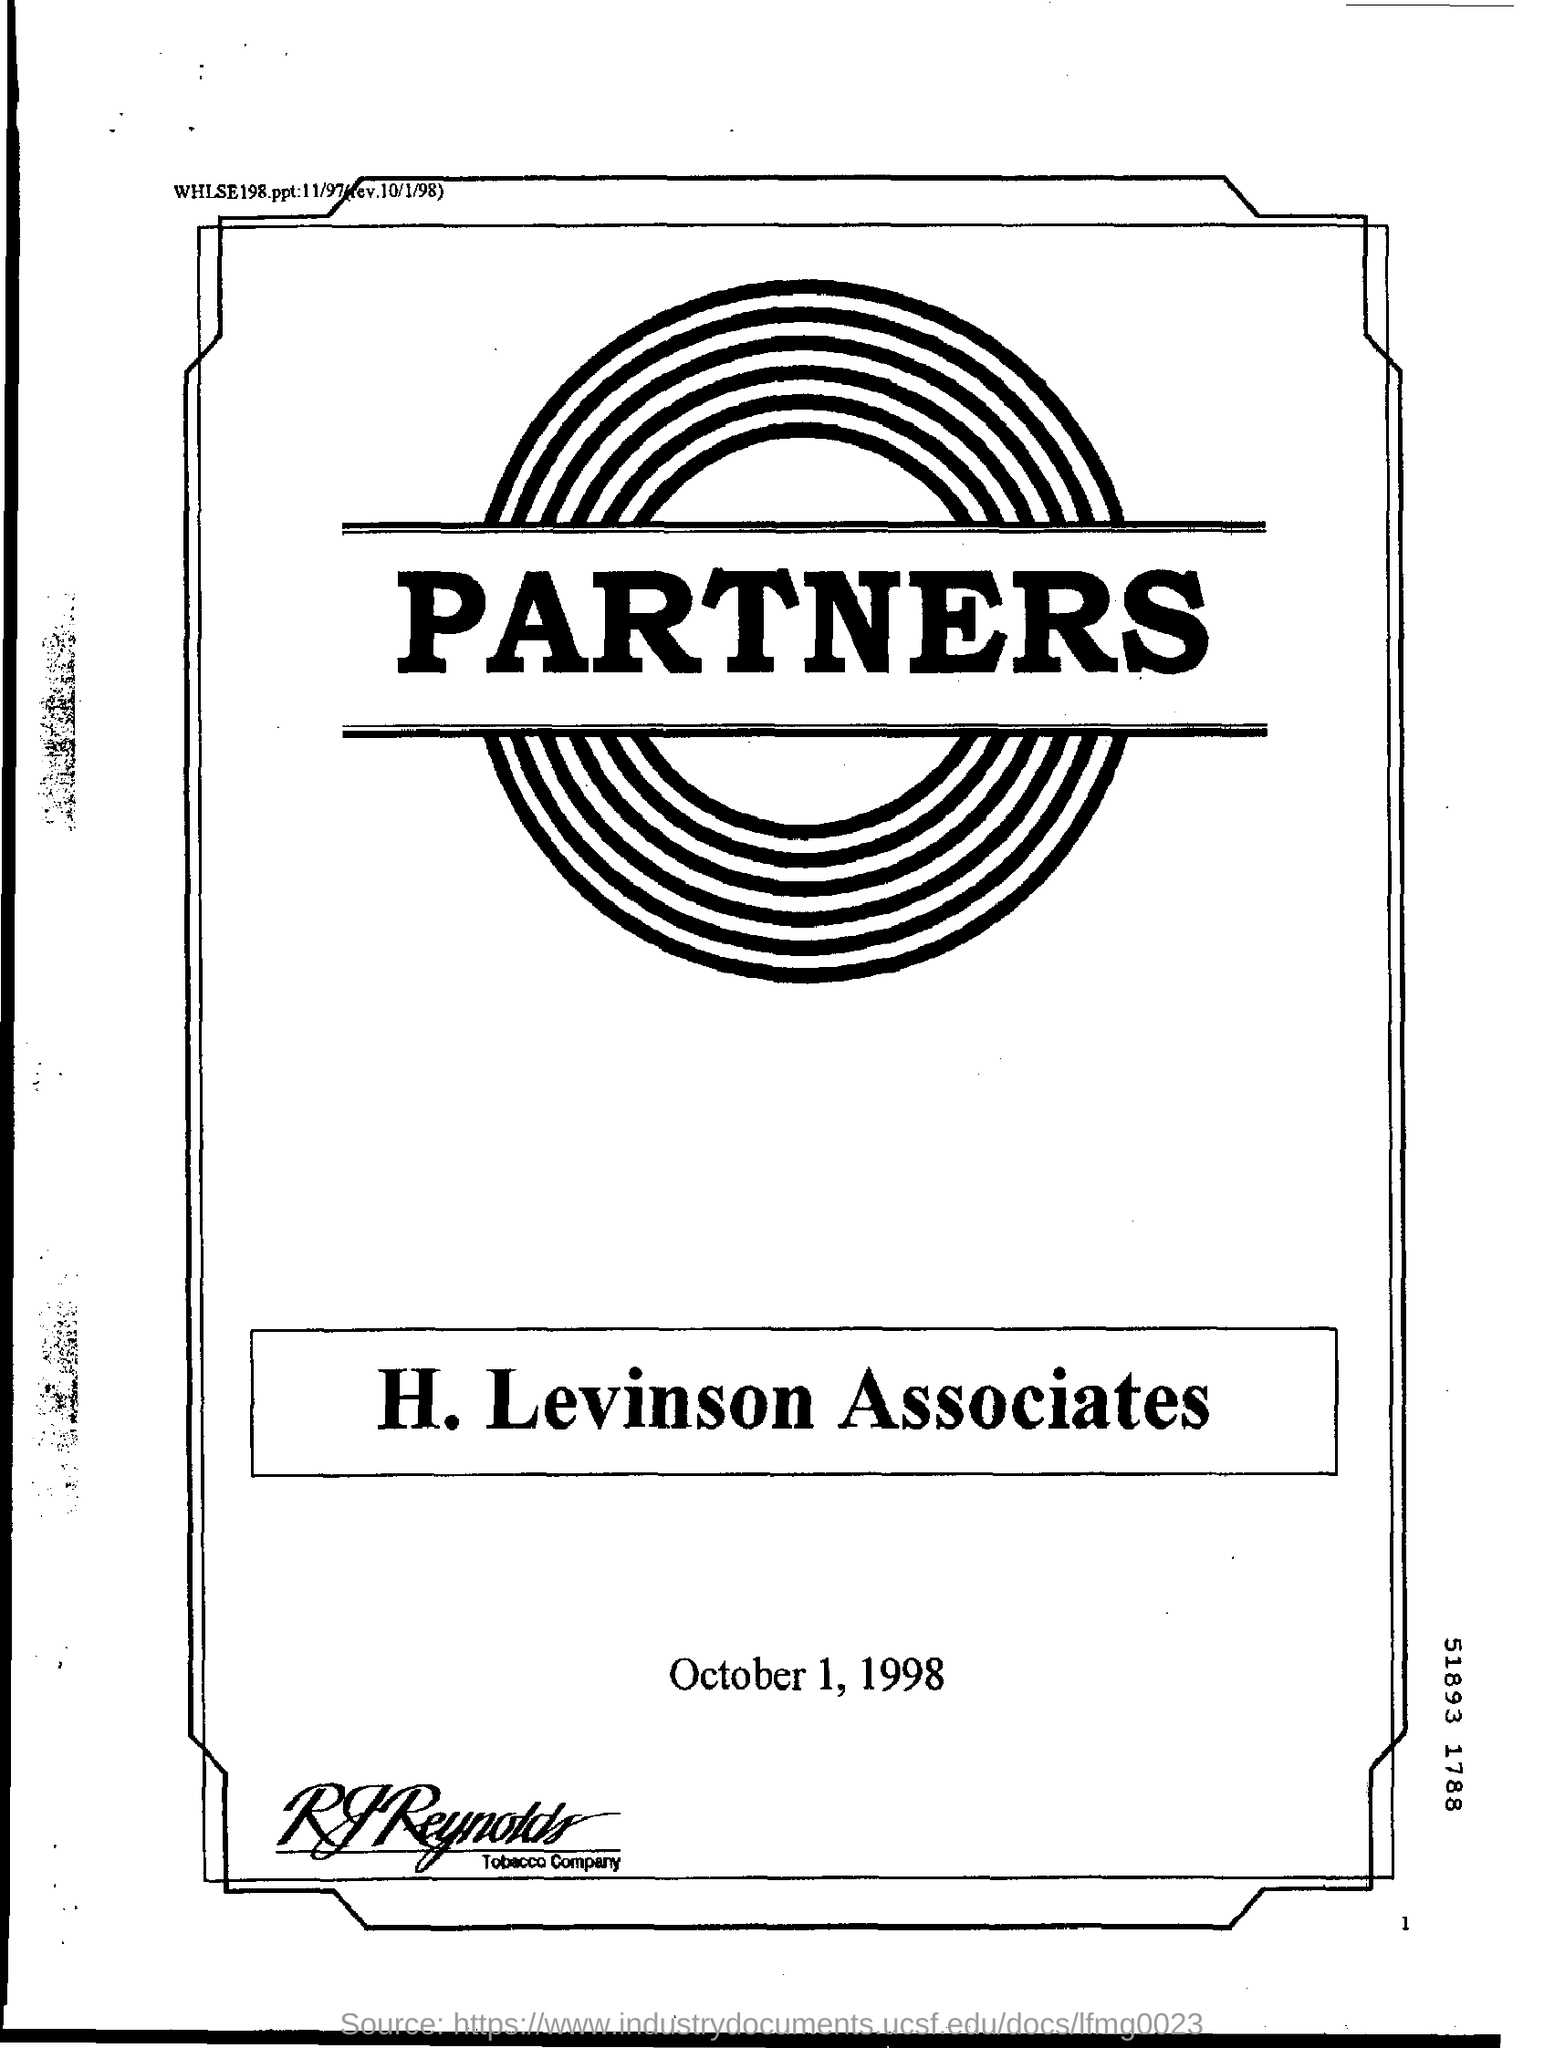What is the name seen on the logo?
Make the answer very short. PARTNERS. What is the name of the Associates?
Give a very brief answer. H. Levinson. What is the date mentioned?
Make the answer very short. October 1, 1998. Which company's name is mentioned at the bottom?
Give a very brief answer. RJ Reynolds. 